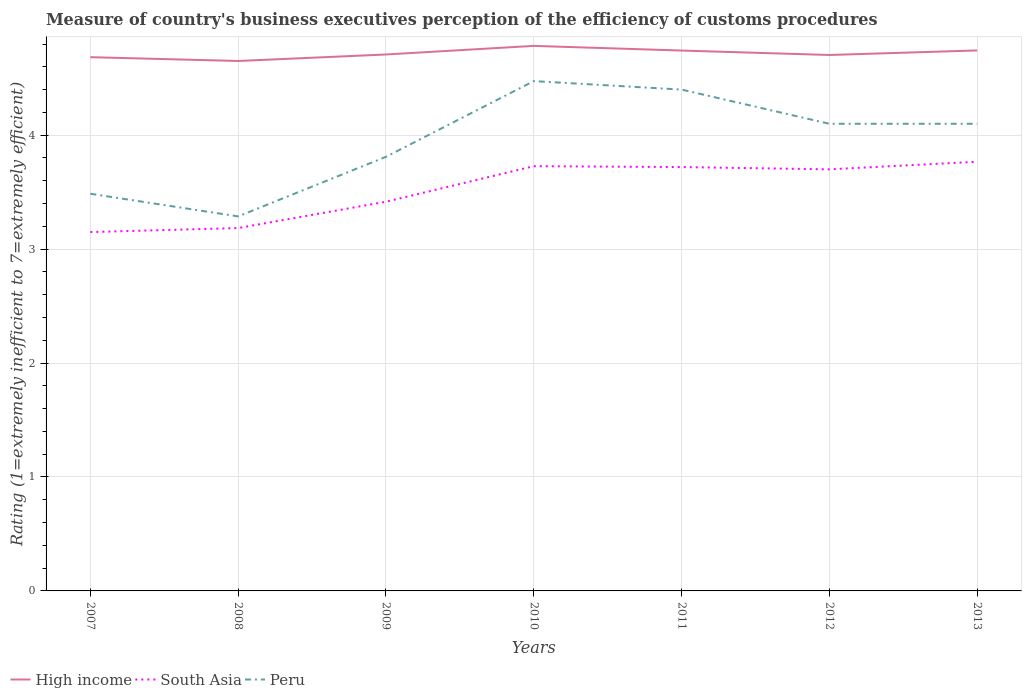How many different coloured lines are there?
Provide a succinct answer. 3. Across all years, what is the maximum rating of the efficiency of customs procedure in South Asia?
Provide a short and direct response. 3.15. What is the total rating of the efficiency of customs procedure in High income in the graph?
Offer a terse response. 0.04. What is the difference between the highest and the second highest rating of the efficiency of customs procedure in High income?
Provide a short and direct response. 0.13. How many lines are there?
Make the answer very short. 3. How many years are there in the graph?
Give a very brief answer. 7. Are the values on the major ticks of Y-axis written in scientific E-notation?
Make the answer very short. No. Does the graph contain any zero values?
Keep it short and to the point. No. Does the graph contain grids?
Your answer should be very brief. Yes. Where does the legend appear in the graph?
Your answer should be very brief. Bottom left. How many legend labels are there?
Your answer should be very brief. 3. How are the legend labels stacked?
Provide a succinct answer. Horizontal. What is the title of the graph?
Make the answer very short. Measure of country's business executives perception of the efficiency of customs procedures. Does "Bahamas" appear as one of the legend labels in the graph?
Your response must be concise. No. What is the label or title of the Y-axis?
Provide a short and direct response. Rating (1=extremely inefficient to 7=extremely efficient). What is the Rating (1=extremely inefficient to 7=extremely efficient) of High income in 2007?
Keep it short and to the point. 4.68. What is the Rating (1=extremely inefficient to 7=extremely efficient) in South Asia in 2007?
Your response must be concise. 3.15. What is the Rating (1=extremely inefficient to 7=extremely efficient) in Peru in 2007?
Give a very brief answer. 3.49. What is the Rating (1=extremely inefficient to 7=extremely efficient) in High income in 2008?
Provide a succinct answer. 4.65. What is the Rating (1=extremely inefficient to 7=extremely efficient) in South Asia in 2008?
Your answer should be compact. 3.18. What is the Rating (1=extremely inefficient to 7=extremely efficient) of Peru in 2008?
Give a very brief answer. 3.29. What is the Rating (1=extremely inefficient to 7=extremely efficient) in High income in 2009?
Your answer should be very brief. 4.71. What is the Rating (1=extremely inefficient to 7=extremely efficient) of South Asia in 2009?
Offer a very short reply. 3.42. What is the Rating (1=extremely inefficient to 7=extremely efficient) of Peru in 2009?
Provide a succinct answer. 3.81. What is the Rating (1=extremely inefficient to 7=extremely efficient) of High income in 2010?
Give a very brief answer. 4.78. What is the Rating (1=extremely inefficient to 7=extremely efficient) of South Asia in 2010?
Your answer should be compact. 3.73. What is the Rating (1=extremely inefficient to 7=extremely efficient) of Peru in 2010?
Give a very brief answer. 4.47. What is the Rating (1=extremely inefficient to 7=extremely efficient) in High income in 2011?
Your answer should be very brief. 4.74. What is the Rating (1=extremely inefficient to 7=extremely efficient) of South Asia in 2011?
Your answer should be compact. 3.72. What is the Rating (1=extremely inefficient to 7=extremely efficient) in Peru in 2011?
Your answer should be very brief. 4.4. What is the Rating (1=extremely inefficient to 7=extremely efficient) of High income in 2012?
Keep it short and to the point. 4.7. What is the Rating (1=extremely inefficient to 7=extremely efficient) in High income in 2013?
Your answer should be compact. 4.74. What is the Rating (1=extremely inefficient to 7=extremely efficient) in South Asia in 2013?
Offer a terse response. 3.77. Across all years, what is the maximum Rating (1=extremely inefficient to 7=extremely efficient) in High income?
Keep it short and to the point. 4.78. Across all years, what is the maximum Rating (1=extremely inefficient to 7=extremely efficient) of South Asia?
Offer a very short reply. 3.77. Across all years, what is the maximum Rating (1=extremely inefficient to 7=extremely efficient) in Peru?
Provide a short and direct response. 4.47. Across all years, what is the minimum Rating (1=extremely inefficient to 7=extremely efficient) in High income?
Provide a short and direct response. 4.65. Across all years, what is the minimum Rating (1=extremely inefficient to 7=extremely efficient) in South Asia?
Ensure brevity in your answer.  3.15. Across all years, what is the minimum Rating (1=extremely inefficient to 7=extremely efficient) in Peru?
Keep it short and to the point. 3.29. What is the total Rating (1=extremely inefficient to 7=extremely efficient) of High income in the graph?
Give a very brief answer. 33.02. What is the total Rating (1=extremely inefficient to 7=extremely efficient) of South Asia in the graph?
Your response must be concise. 24.66. What is the total Rating (1=extremely inefficient to 7=extremely efficient) in Peru in the graph?
Your answer should be very brief. 27.66. What is the difference between the Rating (1=extremely inefficient to 7=extremely efficient) of High income in 2007 and that in 2008?
Give a very brief answer. 0.03. What is the difference between the Rating (1=extremely inefficient to 7=extremely efficient) of South Asia in 2007 and that in 2008?
Make the answer very short. -0.04. What is the difference between the Rating (1=extremely inefficient to 7=extremely efficient) of Peru in 2007 and that in 2008?
Offer a very short reply. 0.2. What is the difference between the Rating (1=extremely inefficient to 7=extremely efficient) in High income in 2007 and that in 2009?
Offer a very short reply. -0.02. What is the difference between the Rating (1=extremely inefficient to 7=extremely efficient) in South Asia in 2007 and that in 2009?
Your answer should be compact. -0.27. What is the difference between the Rating (1=extremely inefficient to 7=extremely efficient) of Peru in 2007 and that in 2009?
Your response must be concise. -0.32. What is the difference between the Rating (1=extremely inefficient to 7=extremely efficient) in High income in 2007 and that in 2010?
Your response must be concise. -0.1. What is the difference between the Rating (1=extremely inefficient to 7=extremely efficient) of South Asia in 2007 and that in 2010?
Offer a terse response. -0.58. What is the difference between the Rating (1=extremely inefficient to 7=extremely efficient) in Peru in 2007 and that in 2010?
Offer a terse response. -0.99. What is the difference between the Rating (1=extremely inefficient to 7=extremely efficient) of High income in 2007 and that in 2011?
Provide a succinct answer. -0.06. What is the difference between the Rating (1=extremely inefficient to 7=extremely efficient) of South Asia in 2007 and that in 2011?
Your answer should be very brief. -0.57. What is the difference between the Rating (1=extremely inefficient to 7=extremely efficient) in Peru in 2007 and that in 2011?
Your answer should be very brief. -0.91. What is the difference between the Rating (1=extremely inefficient to 7=extremely efficient) of High income in 2007 and that in 2012?
Offer a very short reply. -0.02. What is the difference between the Rating (1=extremely inefficient to 7=extremely efficient) of South Asia in 2007 and that in 2012?
Your answer should be very brief. -0.55. What is the difference between the Rating (1=extremely inefficient to 7=extremely efficient) of Peru in 2007 and that in 2012?
Your answer should be compact. -0.61. What is the difference between the Rating (1=extremely inefficient to 7=extremely efficient) of High income in 2007 and that in 2013?
Keep it short and to the point. -0.06. What is the difference between the Rating (1=extremely inefficient to 7=extremely efficient) of South Asia in 2007 and that in 2013?
Give a very brief answer. -0.62. What is the difference between the Rating (1=extremely inefficient to 7=extremely efficient) of Peru in 2007 and that in 2013?
Offer a very short reply. -0.61. What is the difference between the Rating (1=extremely inefficient to 7=extremely efficient) in High income in 2008 and that in 2009?
Provide a short and direct response. -0.06. What is the difference between the Rating (1=extremely inefficient to 7=extremely efficient) in South Asia in 2008 and that in 2009?
Your answer should be very brief. -0.23. What is the difference between the Rating (1=extremely inefficient to 7=extremely efficient) of Peru in 2008 and that in 2009?
Ensure brevity in your answer.  -0.52. What is the difference between the Rating (1=extremely inefficient to 7=extremely efficient) of High income in 2008 and that in 2010?
Your answer should be very brief. -0.13. What is the difference between the Rating (1=extremely inefficient to 7=extremely efficient) of South Asia in 2008 and that in 2010?
Offer a very short reply. -0.54. What is the difference between the Rating (1=extremely inefficient to 7=extremely efficient) in Peru in 2008 and that in 2010?
Your response must be concise. -1.19. What is the difference between the Rating (1=extremely inefficient to 7=extremely efficient) of High income in 2008 and that in 2011?
Give a very brief answer. -0.09. What is the difference between the Rating (1=extremely inefficient to 7=extremely efficient) of South Asia in 2008 and that in 2011?
Keep it short and to the point. -0.54. What is the difference between the Rating (1=extremely inefficient to 7=extremely efficient) in Peru in 2008 and that in 2011?
Make the answer very short. -1.11. What is the difference between the Rating (1=extremely inefficient to 7=extremely efficient) of High income in 2008 and that in 2012?
Offer a very short reply. -0.05. What is the difference between the Rating (1=extremely inefficient to 7=extremely efficient) of South Asia in 2008 and that in 2012?
Keep it short and to the point. -0.52. What is the difference between the Rating (1=extremely inefficient to 7=extremely efficient) of Peru in 2008 and that in 2012?
Offer a very short reply. -0.81. What is the difference between the Rating (1=extremely inefficient to 7=extremely efficient) in High income in 2008 and that in 2013?
Make the answer very short. -0.09. What is the difference between the Rating (1=extremely inefficient to 7=extremely efficient) of South Asia in 2008 and that in 2013?
Keep it short and to the point. -0.58. What is the difference between the Rating (1=extremely inefficient to 7=extremely efficient) in Peru in 2008 and that in 2013?
Make the answer very short. -0.81. What is the difference between the Rating (1=extremely inefficient to 7=extremely efficient) in High income in 2009 and that in 2010?
Your response must be concise. -0.08. What is the difference between the Rating (1=extremely inefficient to 7=extremely efficient) of South Asia in 2009 and that in 2010?
Your answer should be compact. -0.31. What is the difference between the Rating (1=extremely inefficient to 7=extremely efficient) of Peru in 2009 and that in 2010?
Ensure brevity in your answer.  -0.66. What is the difference between the Rating (1=extremely inefficient to 7=extremely efficient) in High income in 2009 and that in 2011?
Your answer should be compact. -0.03. What is the difference between the Rating (1=extremely inefficient to 7=extremely efficient) in South Asia in 2009 and that in 2011?
Keep it short and to the point. -0.3. What is the difference between the Rating (1=extremely inefficient to 7=extremely efficient) of Peru in 2009 and that in 2011?
Your answer should be very brief. -0.59. What is the difference between the Rating (1=extremely inefficient to 7=extremely efficient) in High income in 2009 and that in 2012?
Make the answer very short. 0. What is the difference between the Rating (1=extremely inefficient to 7=extremely efficient) in South Asia in 2009 and that in 2012?
Make the answer very short. -0.28. What is the difference between the Rating (1=extremely inefficient to 7=extremely efficient) of Peru in 2009 and that in 2012?
Offer a very short reply. -0.29. What is the difference between the Rating (1=extremely inefficient to 7=extremely efficient) of High income in 2009 and that in 2013?
Your answer should be very brief. -0.04. What is the difference between the Rating (1=extremely inefficient to 7=extremely efficient) of South Asia in 2009 and that in 2013?
Provide a succinct answer. -0.35. What is the difference between the Rating (1=extremely inefficient to 7=extremely efficient) of Peru in 2009 and that in 2013?
Your answer should be very brief. -0.29. What is the difference between the Rating (1=extremely inefficient to 7=extremely efficient) in High income in 2010 and that in 2011?
Offer a terse response. 0.04. What is the difference between the Rating (1=extremely inefficient to 7=extremely efficient) of South Asia in 2010 and that in 2011?
Make the answer very short. 0.01. What is the difference between the Rating (1=extremely inefficient to 7=extremely efficient) of Peru in 2010 and that in 2011?
Keep it short and to the point. 0.07. What is the difference between the Rating (1=extremely inefficient to 7=extremely efficient) in High income in 2010 and that in 2012?
Keep it short and to the point. 0.08. What is the difference between the Rating (1=extremely inefficient to 7=extremely efficient) in South Asia in 2010 and that in 2012?
Offer a very short reply. 0.03. What is the difference between the Rating (1=extremely inefficient to 7=extremely efficient) of Peru in 2010 and that in 2012?
Provide a succinct answer. 0.37. What is the difference between the Rating (1=extremely inefficient to 7=extremely efficient) of High income in 2010 and that in 2013?
Make the answer very short. 0.04. What is the difference between the Rating (1=extremely inefficient to 7=extremely efficient) of South Asia in 2010 and that in 2013?
Ensure brevity in your answer.  -0.04. What is the difference between the Rating (1=extremely inefficient to 7=extremely efficient) of Peru in 2010 and that in 2013?
Give a very brief answer. 0.37. What is the difference between the Rating (1=extremely inefficient to 7=extremely efficient) of High income in 2011 and that in 2012?
Make the answer very short. 0.04. What is the difference between the Rating (1=extremely inefficient to 7=extremely efficient) of South Asia in 2011 and that in 2012?
Ensure brevity in your answer.  0.02. What is the difference between the Rating (1=extremely inefficient to 7=extremely efficient) in High income in 2011 and that in 2013?
Keep it short and to the point. -0. What is the difference between the Rating (1=extremely inefficient to 7=extremely efficient) in South Asia in 2011 and that in 2013?
Offer a very short reply. -0.05. What is the difference between the Rating (1=extremely inefficient to 7=extremely efficient) in High income in 2012 and that in 2013?
Give a very brief answer. -0.04. What is the difference between the Rating (1=extremely inefficient to 7=extremely efficient) of South Asia in 2012 and that in 2013?
Offer a terse response. -0.07. What is the difference between the Rating (1=extremely inefficient to 7=extremely efficient) of Peru in 2012 and that in 2013?
Ensure brevity in your answer.  0. What is the difference between the Rating (1=extremely inefficient to 7=extremely efficient) in High income in 2007 and the Rating (1=extremely inefficient to 7=extremely efficient) in South Asia in 2008?
Provide a succinct answer. 1.5. What is the difference between the Rating (1=extremely inefficient to 7=extremely efficient) of High income in 2007 and the Rating (1=extremely inefficient to 7=extremely efficient) of Peru in 2008?
Offer a very short reply. 1.4. What is the difference between the Rating (1=extremely inefficient to 7=extremely efficient) of South Asia in 2007 and the Rating (1=extremely inefficient to 7=extremely efficient) of Peru in 2008?
Give a very brief answer. -0.14. What is the difference between the Rating (1=extremely inefficient to 7=extremely efficient) of High income in 2007 and the Rating (1=extremely inefficient to 7=extremely efficient) of South Asia in 2009?
Keep it short and to the point. 1.27. What is the difference between the Rating (1=extremely inefficient to 7=extremely efficient) of High income in 2007 and the Rating (1=extremely inefficient to 7=extremely efficient) of Peru in 2009?
Offer a terse response. 0.87. What is the difference between the Rating (1=extremely inefficient to 7=extremely efficient) of South Asia in 2007 and the Rating (1=extremely inefficient to 7=extremely efficient) of Peru in 2009?
Provide a succinct answer. -0.66. What is the difference between the Rating (1=extremely inefficient to 7=extremely efficient) in High income in 2007 and the Rating (1=extremely inefficient to 7=extremely efficient) in South Asia in 2010?
Provide a short and direct response. 0.96. What is the difference between the Rating (1=extremely inefficient to 7=extremely efficient) of High income in 2007 and the Rating (1=extremely inefficient to 7=extremely efficient) of Peru in 2010?
Ensure brevity in your answer.  0.21. What is the difference between the Rating (1=extremely inefficient to 7=extremely efficient) of South Asia in 2007 and the Rating (1=extremely inefficient to 7=extremely efficient) of Peru in 2010?
Offer a terse response. -1.32. What is the difference between the Rating (1=extremely inefficient to 7=extremely efficient) of High income in 2007 and the Rating (1=extremely inefficient to 7=extremely efficient) of South Asia in 2011?
Your answer should be very brief. 0.96. What is the difference between the Rating (1=extremely inefficient to 7=extremely efficient) in High income in 2007 and the Rating (1=extremely inefficient to 7=extremely efficient) in Peru in 2011?
Keep it short and to the point. 0.28. What is the difference between the Rating (1=extremely inefficient to 7=extremely efficient) of South Asia in 2007 and the Rating (1=extremely inefficient to 7=extremely efficient) of Peru in 2011?
Offer a terse response. -1.25. What is the difference between the Rating (1=extremely inefficient to 7=extremely efficient) in High income in 2007 and the Rating (1=extremely inefficient to 7=extremely efficient) in South Asia in 2012?
Offer a very short reply. 0.98. What is the difference between the Rating (1=extremely inefficient to 7=extremely efficient) of High income in 2007 and the Rating (1=extremely inefficient to 7=extremely efficient) of Peru in 2012?
Your answer should be compact. 0.58. What is the difference between the Rating (1=extremely inefficient to 7=extremely efficient) of South Asia in 2007 and the Rating (1=extremely inefficient to 7=extremely efficient) of Peru in 2012?
Offer a terse response. -0.95. What is the difference between the Rating (1=extremely inefficient to 7=extremely efficient) of High income in 2007 and the Rating (1=extremely inefficient to 7=extremely efficient) of South Asia in 2013?
Offer a very short reply. 0.92. What is the difference between the Rating (1=extremely inefficient to 7=extremely efficient) in High income in 2007 and the Rating (1=extremely inefficient to 7=extremely efficient) in Peru in 2013?
Keep it short and to the point. 0.58. What is the difference between the Rating (1=extremely inefficient to 7=extremely efficient) in South Asia in 2007 and the Rating (1=extremely inefficient to 7=extremely efficient) in Peru in 2013?
Provide a short and direct response. -0.95. What is the difference between the Rating (1=extremely inefficient to 7=extremely efficient) in High income in 2008 and the Rating (1=extremely inefficient to 7=extremely efficient) in South Asia in 2009?
Offer a very short reply. 1.24. What is the difference between the Rating (1=extremely inefficient to 7=extremely efficient) in High income in 2008 and the Rating (1=extremely inefficient to 7=extremely efficient) in Peru in 2009?
Offer a very short reply. 0.84. What is the difference between the Rating (1=extremely inefficient to 7=extremely efficient) in South Asia in 2008 and the Rating (1=extremely inefficient to 7=extremely efficient) in Peru in 2009?
Your answer should be compact. -0.63. What is the difference between the Rating (1=extremely inefficient to 7=extremely efficient) of High income in 2008 and the Rating (1=extremely inefficient to 7=extremely efficient) of South Asia in 2010?
Your response must be concise. 0.92. What is the difference between the Rating (1=extremely inefficient to 7=extremely efficient) in High income in 2008 and the Rating (1=extremely inefficient to 7=extremely efficient) in Peru in 2010?
Provide a short and direct response. 0.18. What is the difference between the Rating (1=extremely inefficient to 7=extremely efficient) in South Asia in 2008 and the Rating (1=extremely inefficient to 7=extremely efficient) in Peru in 2010?
Offer a very short reply. -1.29. What is the difference between the Rating (1=extremely inefficient to 7=extremely efficient) of High income in 2008 and the Rating (1=extremely inefficient to 7=extremely efficient) of South Asia in 2011?
Ensure brevity in your answer.  0.93. What is the difference between the Rating (1=extremely inefficient to 7=extremely efficient) of High income in 2008 and the Rating (1=extremely inefficient to 7=extremely efficient) of Peru in 2011?
Offer a terse response. 0.25. What is the difference between the Rating (1=extremely inefficient to 7=extremely efficient) in South Asia in 2008 and the Rating (1=extremely inefficient to 7=extremely efficient) in Peru in 2011?
Ensure brevity in your answer.  -1.22. What is the difference between the Rating (1=extremely inefficient to 7=extremely efficient) of High income in 2008 and the Rating (1=extremely inefficient to 7=extremely efficient) of South Asia in 2012?
Offer a very short reply. 0.95. What is the difference between the Rating (1=extremely inefficient to 7=extremely efficient) of High income in 2008 and the Rating (1=extremely inefficient to 7=extremely efficient) of Peru in 2012?
Your answer should be compact. 0.55. What is the difference between the Rating (1=extremely inefficient to 7=extremely efficient) of South Asia in 2008 and the Rating (1=extremely inefficient to 7=extremely efficient) of Peru in 2012?
Ensure brevity in your answer.  -0.92. What is the difference between the Rating (1=extremely inefficient to 7=extremely efficient) in High income in 2008 and the Rating (1=extremely inefficient to 7=extremely efficient) in South Asia in 2013?
Your answer should be compact. 0.88. What is the difference between the Rating (1=extremely inefficient to 7=extremely efficient) in High income in 2008 and the Rating (1=extremely inefficient to 7=extremely efficient) in Peru in 2013?
Provide a succinct answer. 0.55. What is the difference between the Rating (1=extremely inefficient to 7=extremely efficient) of South Asia in 2008 and the Rating (1=extremely inefficient to 7=extremely efficient) of Peru in 2013?
Your answer should be compact. -0.92. What is the difference between the Rating (1=extremely inefficient to 7=extremely efficient) in High income in 2009 and the Rating (1=extremely inefficient to 7=extremely efficient) in South Asia in 2010?
Provide a succinct answer. 0.98. What is the difference between the Rating (1=extremely inefficient to 7=extremely efficient) in High income in 2009 and the Rating (1=extremely inefficient to 7=extremely efficient) in Peru in 2010?
Provide a short and direct response. 0.23. What is the difference between the Rating (1=extremely inefficient to 7=extremely efficient) in South Asia in 2009 and the Rating (1=extremely inefficient to 7=extremely efficient) in Peru in 2010?
Make the answer very short. -1.06. What is the difference between the Rating (1=extremely inefficient to 7=extremely efficient) in High income in 2009 and the Rating (1=extremely inefficient to 7=extremely efficient) in South Asia in 2011?
Keep it short and to the point. 0.99. What is the difference between the Rating (1=extremely inefficient to 7=extremely efficient) in High income in 2009 and the Rating (1=extremely inefficient to 7=extremely efficient) in Peru in 2011?
Offer a terse response. 0.31. What is the difference between the Rating (1=extremely inefficient to 7=extremely efficient) of South Asia in 2009 and the Rating (1=extremely inefficient to 7=extremely efficient) of Peru in 2011?
Make the answer very short. -0.98. What is the difference between the Rating (1=extremely inefficient to 7=extremely efficient) of High income in 2009 and the Rating (1=extremely inefficient to 7=extremely efficient) of South Asia in 2012?
Your answer should be very brief. 1.01. What is the difference between the Rating (1=extremely inefficient to 7=extremely efficient) of High income in 2009 and the Rating (1=extremely inefficient to 7=extremely efficient) of Peru in 2012?
Make the answer very short. 0.61. What is the difference between the Rating (1=extremely inefficient to 7=extremely efficient) in South Asia in 2009 and the Rating (1=extremely inefficient to 7=extremely efficient) in Peru in 2012?
Your answer should be very brief. -0.68. What is the difference between the Rating (1=extremely inefficient to 7=extremely efficient) in High income in 2009 and the Rating (1=extremely inefficient to 7=extremely efficient) in South Asia in 2013?
Give a very brief answer. 0.94. What is the difference between the Rating (1=extremely inefficient to 7=extremely efficient) in High income in 2009 and the Rating (1=extremely inefficient to 7=extremely efficient) in Peru in 2013?
Provide a succinct answer. 0.61. What is the difference between the Rating (1=extremely inefficient to 7=extremely efficient) of South Asia in 2009 and the Rating (1=extremely inefficient to 7=extremely efficient) of Peru in 2013?
Offer a terse response. -0.68. What is the difference between the Rating (1=extremely inefficient to 7=extremely efficient) in High income in 2010 and the Rating (1=extremely inefficient to 7=extremely efficient) in South Asia in 2011?
Provide a succinct answer. 1.06. What is the difference between the Rating (1=extremely inefficient to 7=extremely efficient) in High income in 2010 and the Rating (1=extremely inefficient to 7=extremely efficient) in Peru in 2011?
Your answer should be compact. 0.38. What is the difference between the Rating (1=extremely inefficient to 7=extremely efficient) in South Asia in 2010 and the Rating (1=extremely inefficient to 7=extremely efficient) in Peru in 2011?
Ensure brevity in your answer.  -0.67. What is the difference between the Rating (1=extremely inefficient to 7=extremely efficient) of High income in 2010 and the Rating (1=extremely inefficient to 7=extremely efficient) of South Asia in 2012?
Your response must be concise. 1.08. What is the difference between the Rating (1=extremely inefficient to 7=extremely efficient) in High income in 2010 and the Rating (1=extremely inefficient to 7=extremely efficient) in Peru in 2012?
Offer a very short reply. 0.68. What is the difference between the Rating (1=extremely inefficient to 7=extremely efficient) in South Asia in 2010 and the Rating (1=extremely inefficient to 7=extremely efficient) in Peru in 2012?
Offer a very short reply. -0.37. What is the difference between the Rating (1=extremely inefficient to 7=extremely efficient) in High income in 2010 and the Rating (1=extremely inefficient to 7=extremely efficient) in South Asia in 2013?
Keep it short and to the point. 1.02. What is the difference between the Rating (1=extremely inefficient to 7=extremely efficient) of High income in 2010 and the Rating (1=extremely inefficient to 7=extremely efficient) of Peru in 2013?
Make the answer very short. 0.68. What is the difference between the Rating (1=extremely inefficient to 7=extremely efficient) in South Asia in 2010 and the Rating (1=extremely inefficient to 7=extremely efficient) in Peru in 2013?
Offer a terse response. -0.37. What is the difference between the Rating (1=extremely inefficient to 7=extremely efficient) in High income in 2011 and the Rating (1=extremely inefficient to 7=extremely efficient) in South Asia in 2012?
Provide a succinct answer. 1.04. What is the difference between the Rating (1=extremely inefficient to 7=extremely efficient) of High income in 2011 and the Rating (1=extremely inefficient to 7=extremely efficient) of Peru in 2012?
Provide a short and direct response. 0.64. What is the difference between the Rating (1=extremely inefficient to 7=extremely efficient) of South Asia in 2011 and the Rating (1=extremely inefficient to 7=extremely efficient) of Peru in 2012?
Ensure brevity in your answer.  -0.38. What is the difference between the Rating (1=extremely inefficient to 7=extremely efficient) in High income in 2011 and the Rating (1=extremely inefficient to 7=extremely efficient) in South Asia in 2013?
Keep it short and to the point. 0.98. What is the difference between the Rating (1=extremely inefficient to 7=extremely efficient) of High income in 2011 and the Rating (1=extremely inefficient to 7=extremely efficient) of Peru in 2013?
Your response must be concise. 0.64. What is the difference between the Rating (1=extremely inefficient to 7=extremely efficient) of South Asia in 2011 and the Rating (1=extremely inefficient to 7=extremely efficient) of Peru in 2013?
Provide a succinct answer. -0.38. What is the difference between the Rating (1=extremely inefficient to 7=extremely efficient) of High income in 2012 and the Rating (1=extremely inefficient to 7=extremely efficient) of South Asia in 2013?
Your response must be concise. 0.94. What is the difference between the Rating (1=extremely inefficient to 7=extremely efficient) of High income in 2012 and the Rating (1=extremely inefficient to 7=extremely efficient) of Peru in 2013?
Ensure brevity in your answer.  0.6. What is the average Rating (1=extremely inefficient to 7=extremely efficient) in High income per year?
Keep it short and to the point. 4.72. What is the average Rating (1=extremely inefficient to 7=extremely efficient) of South Asia per year?
Provide a short and direct response. 3.52. What is the average Rating (1=extremely inefficient to 7=extremely efficient) in Peru per year?
Provide a succinct answer. 3.95. In the year 2007, what is the difference between the Rating (1=extremely inefficient to 7=extremely efficient) of High income and Rating (1=extremely inefficient to 7=extremely efficient) of South Asia?
Offer a very short reply. 1.53. In the year 2007, what is the difference between the Rating (1=extremely inefficient to 7=extremely efficient) of High income and Rating (1=extremely inefficient to 7=extremely efficient) of Peru?
Ensure brevity in your answer.  1.2. In the year 2007, what is the difference between the Rating (1=extremely inefficient to 7=extremely efficient) in South Asia and Rating (1=extremely inefficient to 7=extremely efficient) in Peru?
Your response must be concise. -0.34. In the year 2008, what is the difference between the Rating (1=extremely inefficient to 7=extremely efficient) of High income and Rating (1=extremely inefficient to 7=extremely efficient) of South Asia?
Your answer should be very brief. 1.47. In the year 2008, what is the difference between the Rating (1=extremely inefficient to 7=extremely efficient) of High income and Rating (1=extremely inefficient to 7=extremely efficient) of Peru?
Your response must be concise. 1.36. In the year 2008, what is the difference between the Rating (1=extremely inefficient to 7=extremely efficient) of South Asia and Rating (1=extremely inefficient to 7=extremely efficient) of Peru?
Provide a short and direct response. -0.1. In the year 2009, what is the difference between the Rating (1=extremely inefficient to 7=extremely efficient) of High income and Rating (1=extremely inefficient to 7=extremely efficient) of South Asia?
Offer a very short reply. 1.29. In the year 2009, what is the difference between the Rating (1=extremely inefficient to 7=extremely efficient) in High income and Rating (1=extremely inefficient to 7=extremely efficient) in Peru?
Ensure brevity in your answer.  0.9. In the year 2009, what is the difference between the Rating (1=extremely inefficient to 7=extremely efficient) of South Asia and Rating (1=extremely inefficient to 7=extremely efficient) of Peru?
Your response must be concise. -0.39. In the year 2010, what is the difference between the Rating (1=extremely inefficient to 7=extremely efficient) in High income and Rating (1=extremely inefficient to 7=extremely efficient) in South Asia?
Give a very brief answer. 1.06. In the year 2010, what is the difference between the Rating (1=extremely inefficient to 7=extremely efficient) in High income and Rating (1=extremely inefficient to 7=extremely efficient) in Peru?
Keep it short and to the point. 0.31. In the year 2010, what is the difference between the Rating (1=extremely inefficient to 7=extremely efficient) in South Asia and Rating (1=extremely inefficient to 7=extremely efficient) in Peru?
Provide a succinct answer. -0.75. In the year 2011, what is the difference between the Rating (1=extremely inefficient to 7=extremely efficient) of High income and Rating (1=extremely inefficient to 7=extremely efficient) of South Asia?
Your response must be concise. 1.02. In the year 2011, what is the difference between the Rating (1=extremely inefficient to 7=extremely efficient) in High income and Rating (1=extremely inefficient to 7=extremely efficient) in Peru?
Ensure brevity in your answer.  0.34. In the year 2011, what is the difference between the Rating (1=extremely inefficient to 7=extremely efficient) in South Asia and Rating (1=extremely inefficient to 7=extremely efficient) in Peru?
Offer a terse response. -0.68. In the year 2012, what is the difference between the Rating (1=extremely inefficient to 7=extremely efficient) of High income and Rating (1=extremely inefficient to 7=extremely efficient) of South Asia?
Provide a short and direct response. 1. In the year 2012, what is the difference between the Rating (1=extremely inefficient to 7=extremely efficient) in High income and Rating (1=extremely inefficient to 7=extremely efficient) in Peru?
Offer a terse response. 0.6. In the year 2013, what is the difference between the Rating (1=extremely inefficient to 7=extremely efficient) in High income and Rating (1=extremely inefficient to 7=extremely efficient) in Peru?
Make the answer very short. 0.64. In the year 2013, what is the difference between the Rating (1=extremely inefficient to 7=extremely efficient) in South Asia and Rating (1=extremely inefficient to 7=extremely efficient) in Peru?
Your answer should be compact. -0.33. What is the ratio of the Rating (1=extremely inefficient to 7=extremely efficient) in High income in 2007 to that in 2008?
Your answer should be very brief. 1.01. What is the ratio of the Rating (1=extremely inefficient to 7=extremely efficient) of South Asia in 2007 to that in 2008?
Make the answer very short. 0.99. What is the ratio of the Rating (1=extremely inefficient to 7=extremely efficient) in Peru in 2007 to that in 2008?
Offer a very short reply. 1.06. What is the ratio of the Rating (1=extremely inefficient to 7=extremely efficient) of South Asia in 2007 to that in 2009?
Your response must be concise. 0.92. What is the ratio of the Rating (1=extremely inefficient to 7=extremely efficient) in Peru in 2007 to that in 2009?
Your response must be concise. 0.91. What is the ratio of the Rating (1=extremely inefficient to 7=extremely efficient) in High income in 2007 to that in 2010?
Your answer should be very brief. 0.98. What is the ratio of the Rating (1=extremely inefficient to 7=extremely efficient) in South Asia in 2007 to that in 2010?
Ensure brevity in your answer.  0.84. What is the ratio of the Rating (1=extremely inefficient to 7=extremely efficient) in Peru in 2007 to that in 2010?
Offer a very short reply. 0.78. What is the ratio of the Rating (1=extremely inefficient to 7=extremely efficient) of South Asia in 2007 to that in 2011?
Keep it short and to the point. 0.85. What is the ratio of the Rating (1=extremely inefficient to 7=extremely efficient) of Peru in 2007 to that in 2011?
Your response must be concise. 0.79. What is the ratio of the Rating (1=extremely inefficient to 7=extremely efficient) of South Asia in 2007 to that in 2012?
Provide a succinct answer. 0.85. What is the ratio of the Rating (1=extremely inefficient to 7=extremely efficient) of Peru in 2007 to that in 2012?
Make the answer very short. 0.85. What is the ratio of the Rating (1=extremely inefficient to 7=extremely efficient) in High income in 2007 to that in 2013?
Offer a terse response. 0.99. What is the ratio of the Rating (1=extremely inefficient to 7=extremely efficient) of South Asia in 2007 to that in 2013?
Ensure brevity in your answer.  0.84. What is the ratio of the Rating (1=extremely inefficient to 7=extremely efficient) of Peru in 2007 to that in 2013?
Ensure brevity in your answer.  0.85. What is the ratio of the Rating (1=extremely inefficient to 7=extremely efficient) of High income in 2008 to that in 2009?
Your answer should be very brief. 0.99. What is the ratio of the Rating (1=extremely inefficient to 7=extremely efficient) of South Asia in 2008 to that in 2009?
Your answer should be very brief. 0.93. What is the ratio of the Rating (1=extremely inefficient to 7=extremely efficient) of Peru in 2008 to that in 2009?
Your response must be concise. 0.86. What is the ratio of the Rating (1=extremely inefficient to 7=extremely efficient) of High income in 2008 to that in 2010?
Make the answer very short. 0.97. What is the ratio of the Rating (1=extremely inefficient to 7=extremely efficient) in South Asia in 2008 to that in 2010?
Your response must be concise. 0.85. What is the ratio of the Rating (1=extremely inefficient to 7=extremely efficient) of Peru in 2008 to that in 2010?
Ensure brevity in your answer.  0.73. What is the ratio of the Rating (1=extremely inefficient to 7=extremely efficient) of High income in 2008 to that in 2011?
Ensure brevity in your answer.  0.98. What is the ratio of the Rating (1=extremely inefficient to 7=extremely efficient) in South Asia in 2008 to that in 2011?
Your answer should be very brief. 0.86. What is the ratio of the Rating (1=extremely inefficient to 7=extremely efficient) of Peru in 2008 to that in 2011?
Provide a short and direct response. 0.75. What is the ratio of the Rating (1=extremely inefficient to 7=extremely efficient) in High income in 2008 to that in 2012?
Your response must be concise. 0.99. What is the ratio of the Rating (1=extremely inefficient to 7=extremely efficient) in South Asia in 2008 to that in 2012?
Give a very brief answer. 0.86. What is the ratio of the Rating (1=extremely inefficient to 7=extremely efficient) of Peru in 2008 to that in 2012?
Keep it short and to the point. 0.8. What is the ratio of the Rating (1=extremely inefficient to 7=extremely efficient) in High income in 2008 to that in 2013?
Offer a terse response. 0.98. What is the ratio of the Rating (1=extremely inefficient to 7=extremely efficient) in South Asia in 2008 to that in 2013?
Ensure brevity in your answer.  0.85. What is the ratio of the Rating (1=extremely inefficient to 7=extremely efficient) of Peru in 2008 to that in 2013?
Provide a succinct answer. 0.8. What is the ratio of the Rating (1=extremely inefficient to 7=extremely efficient) of High income in 2009 to that in 2010?
Provide a succinct answer. 0.98. What is the ratio of the Rating (1=extremely inefficient to 7=extremely efficient) of South Asia in 2009 to that in 2010?
Make the answer very short. 0.92. What is the ratio of the Rating (1=extremely inefficient to 7=extremely efficient) of Peru in 2009 to that in 2010?
Provide a short and direct response. 0.85. What is the ratio of the Rating (1=extremely inefficient to 7=extremely efficient) in High income in 2009 to that in 2011?
Make the answer very short. 0.99. What is the ratio of the Rating (1=extremely inefficient to 7=extremely efficient) of South Asia in 2009 to that in 2011?
Offer a terse response. 0.92. What is the ratio of the Rating (1=extremely inefficient to 7=extremely efficient) in Peru in 2009 to that in 2011?
Provide a succinct answer. 0.87. What is the ratio of the Rating (1=extremely inefficient to 7=extremely efficient) in High income in 2009 to that in 2012?
Make the answer very short. 1. What is the ratio of the Rating (1=extremely inefficient to 7=extremely efficient) in South Asia in 2009 to that in 2012?
Your answer should be very brief. 0.92. What is the ratio of the Rating (1=extremely inefficient to 7=extremely efficient) in Peru in 2009 to that in 2012?
Offer a terse response. 0.93. What is the ratio of the Rating (1=extremely inefficient to 7=extremely efficient) in High income in 2009 to that in 2013?
Give a very brief answer. 0.99. What is the ratio of the Rating (1=extremely inefficient to 7=extremely efficient) of South Asia in 2009 to that in 2013?
Offer a very short reply. 0.91. What is the ratio of the Rating (1=extremely inefficient to 7=extremely efficient) of Peru in 2009 to that in 2013?
Give a very brief answer. 0.93. What is the ratio of the Rating (1=extremely inefficient to 7=extremely efficient) of High income in 2010 to that in 2011?
Provide a succinct answer. 1.01. What is the ratio of the Rating (1=extremely inefficient to 7=extremely efficient) in South Asia in 2010 to that in 2011?
Your answer should be compact. 1. What is the ratio of the Rating (1=extremely inefficient to 7=extremely efficient) of Peru in 2010 to that in 2011?
Offer a very short reply. 1.02. What is the ratio of the Rating (1=extremely inefficient to 7=extremely efficient) in High income in 2010 to that in 2012?
Offer a terse response. 1.02. What is the ratio of the Rating (1=extremely inefficient to 7=extremely efficient) in South Asia in 2010 to that in 2012?
Offer a very short reply. 1.01. What is the ratio of the Rating (1=extremely inefficient to 7=extremely efficient) in Peru in 2010 to that in 2012?
Provide a succinct answer. 1.09. What is the ratio of the Rating (1=extremely inefficient to 7=extremely efficient) of High income in 2010 to that in 2013?
Keep it short and to the point. 1.01. What is the ratio of the Rating (1=extremely inefficient to 7=extremely efficient) in South Asia in 2010 to that in 2013?
Your answer should be very brief. 0.99. What is the ratio of the Rating (1=extremely inefficient to 7=extremely efficient) in Peru in 2010 to that in 2013?
Offer a very short reply. 1.09. What is the ratio of the Rating (1=extremely inefficient to 7=extremely efficient) in High income in 2011 to that in 2012?
Ensure brevity in your answer.  1.01. What is the ratio of the Rating (1=extremely inefficient to 7=extremely efficient) in South Asia in 2011 to that in 2012?
Provide a short and direct response. 1.01. What is the ratio of the Rating (1=extremely inefficient to 7=extremely efficient) in Peru in 2011 to that in 2012?
Your answer should be very brief. 1.07. What is the ratio of the Rating (1=extremely inefficient to 7=extremely efficient) in High income in 2011 to that in 2013?
Your response must be concise. 1. What is the ratio of the Rating (1=extremely inefficient to 7=extremely efficient) in South Asia in 2011 to that in 2013?
Offer a terse response. 0.99. What is the ratio of the Rating (1=extremely inefficient to 7=extremely efficient) of Peru in 2011 to that in 2013?
Ensure brevity in your answer.  1.07. What is the ratio of the Rating (1=extremely inefficient to 7=extremely efficient) of South Asia in 2012 to that in 2013?
Your answer should be compact. 0.98. What is the ratio of the Rating (1=extremely inefficient to 7=extremely efficient) in Peru in 2012 to that in 2013?
Offer a very short reply. 1. What is the difference between the highest and the second highest Rating (1=extremely inefficient to 7=extremely efficient) in High income?
Offer a terse response. 0.04. What is the difference between the highest and the second highest Rating (1=extremely inefficient to 7=extremely efficient) of South Asia?
Offer a very short reply. 0.04. What is the difference between the highest and the second highest Rating (1=extremely inefficient to 7=extremely efficient) of Peru?
Keep it short and to the point. 0.07. What is the difference between the highest and the lowest Rating (1=extremely inefficient to 7=extremely efficient) in High income?
Provide a succinct answer. 0.13. What is the difference between the highest and the lowest Rating (1=extremely inefficient to 7=extremely efficient) in South Asia?
Offer a very short reply. 0.62. What is the difference between the highest and the lowest Rating (1=extremely inefficient to 7=extremely efficient) in Peru?
Your answer should be compact. 1.19. 